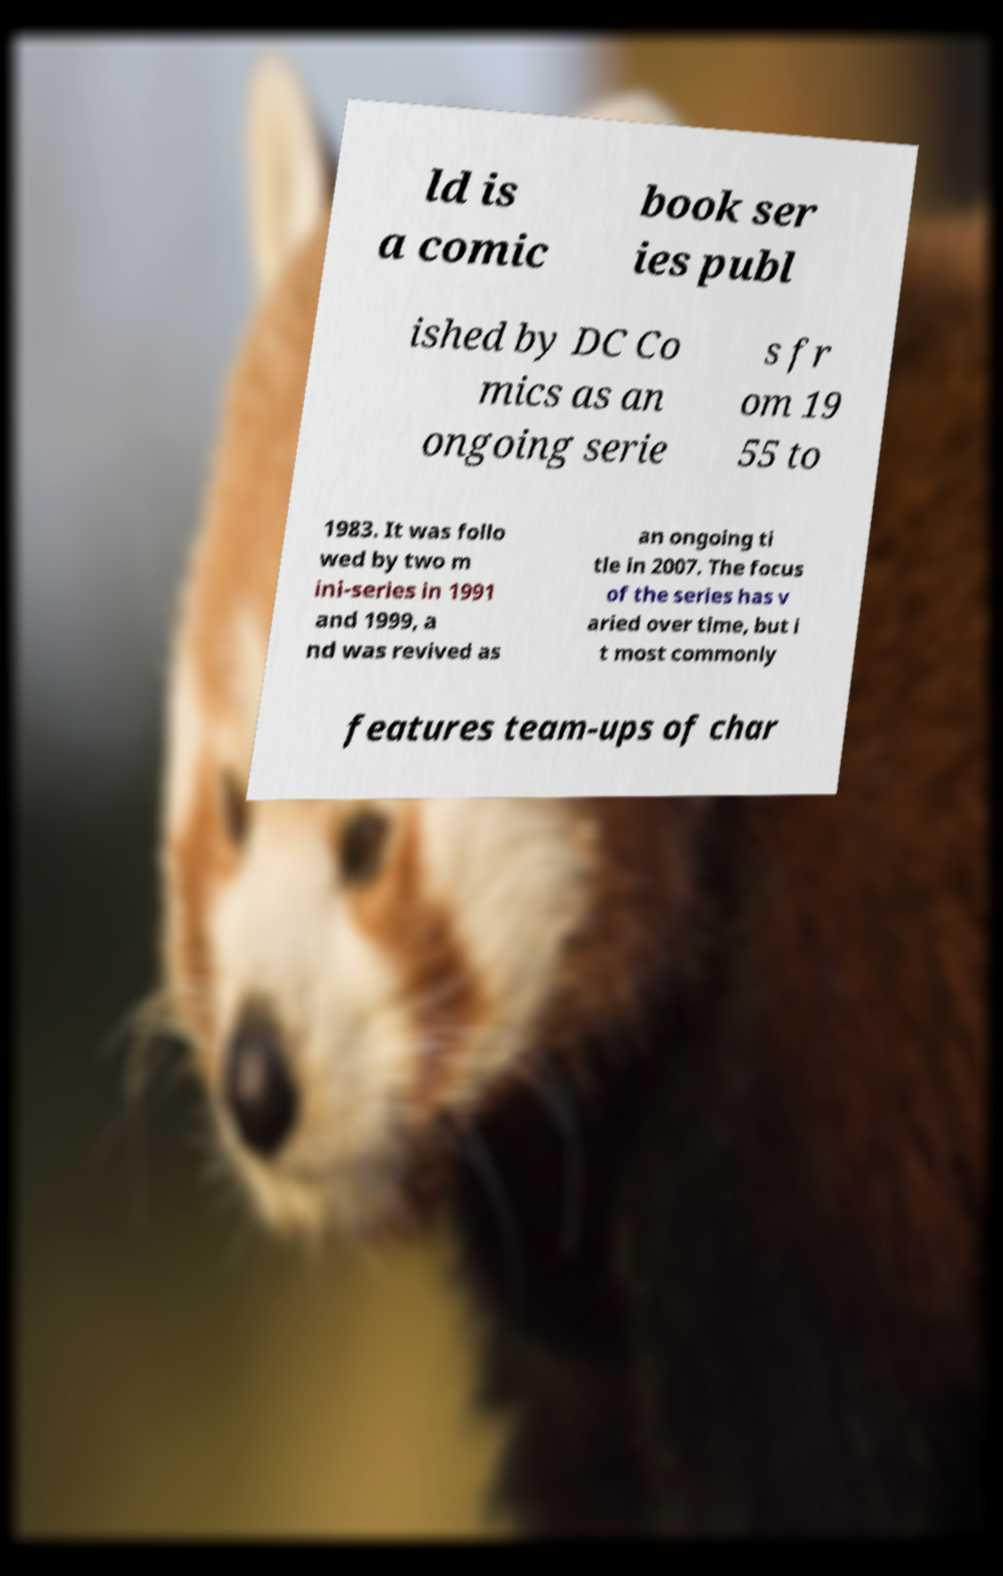There's text embedded in this image that I need extracted. Can you transcribe it verbatim? ld is a comic book ser ies publ ished by DC Co mics as an ongoing serie s fr om 19 55 to 1983. It was follo wed by two m ini-series in 1991 and 1999, a nd was revived as an ongoing ti tle in 2007. The focus of the series has v aried over time, but i t most commonly features team-ups of char 